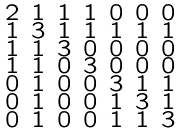Convert formula to latex. <formula><loc_0><loc_0><loc_500><loc_500>\begin{smallmatrix} 2 & 1 & 1 & 1 & 0 & 0 & 0 \\ 1 & 3 & 1 & 1 & 1 & 1 & 1 \\ 1 & 1 & 3 & 0 & 0 & 0 & 0 \\ 1 & 1 & 0 & 3 & 0 & 0 & 0 \\ 0 & 1 & 0 & 0 & 3 & 1 & 1 \\ 0 & 1 & 0 & 0 & 1 & 3 & 1 \\ 0 & 1 & 0 & 0 & 1 & 1 & 3 \end{smallmatrix}</formula> 